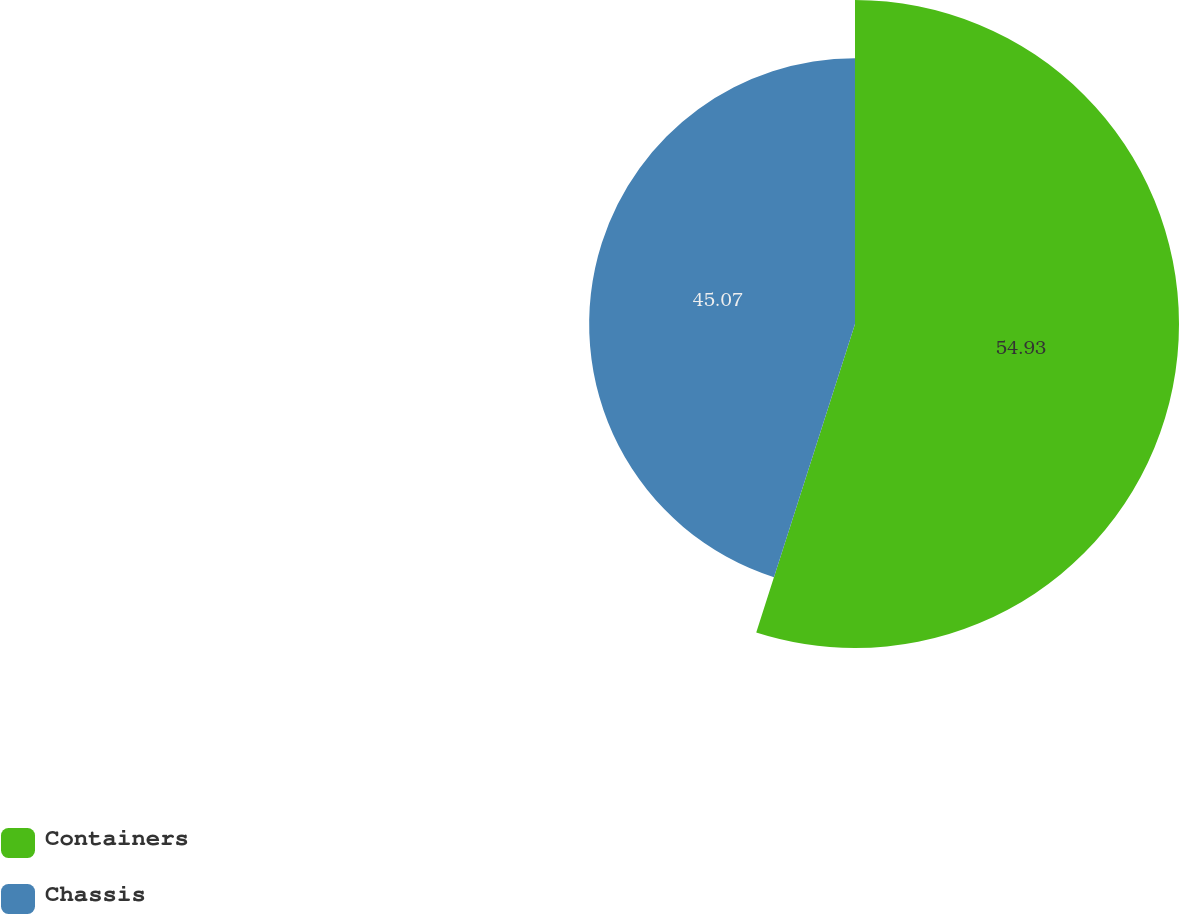Convert chart. <chart><loc_0><loc_0><loc_500><loc_500><pie_chart><fcel>Containers<fcel>Chassis<nl><fcel>54.93%<fcel>45.07%<nl></chart> 